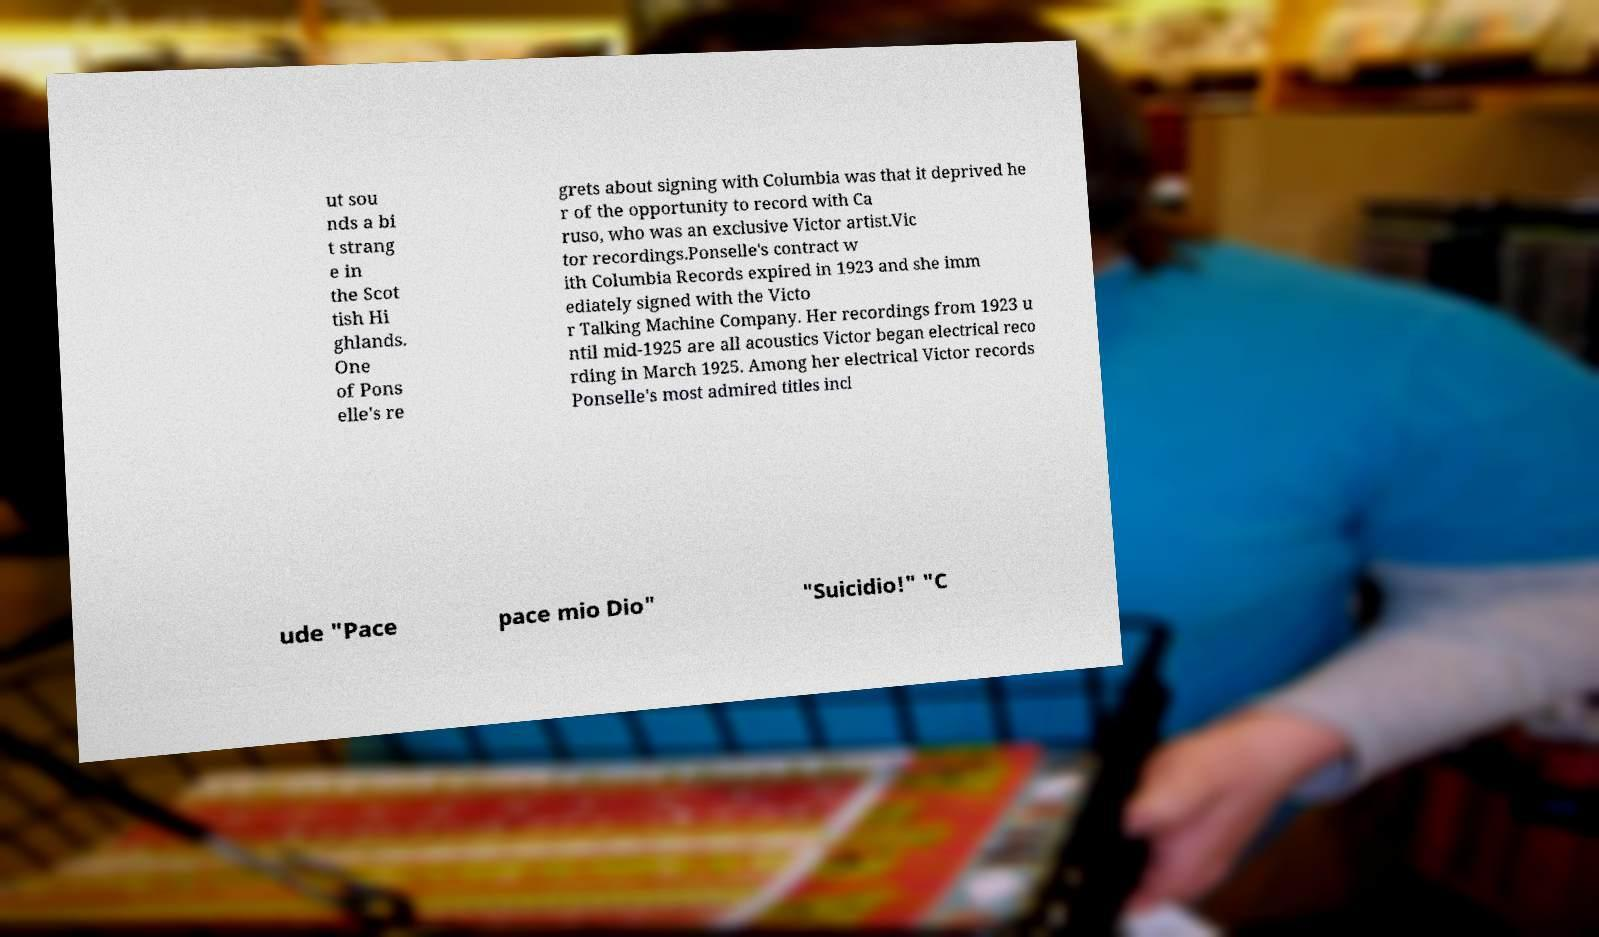I need the written content from this picture converted into text. Can you do that? ut sou nds a bi t strang e in the Scot tish Hi ghlands. One of Pons elle's re grets about signing with Columbia was that it deprived he r of the opportunity to record with Ca ruso, who was an exclusive Victor artist.Vic tor recordings.Ponselle's contract w ith Columbia Records expired in 1923 and she imm ediately signed with the Victo r Talking Machine Company. Her recordings from 1923 u ntil mid-1925 are all acoustics Victor began electrical reco rding in March 1925. Among her electrical Victor records Ponselle's most admired titles incl ude "Pace pace mio Dio" "Suicidio!" "C 